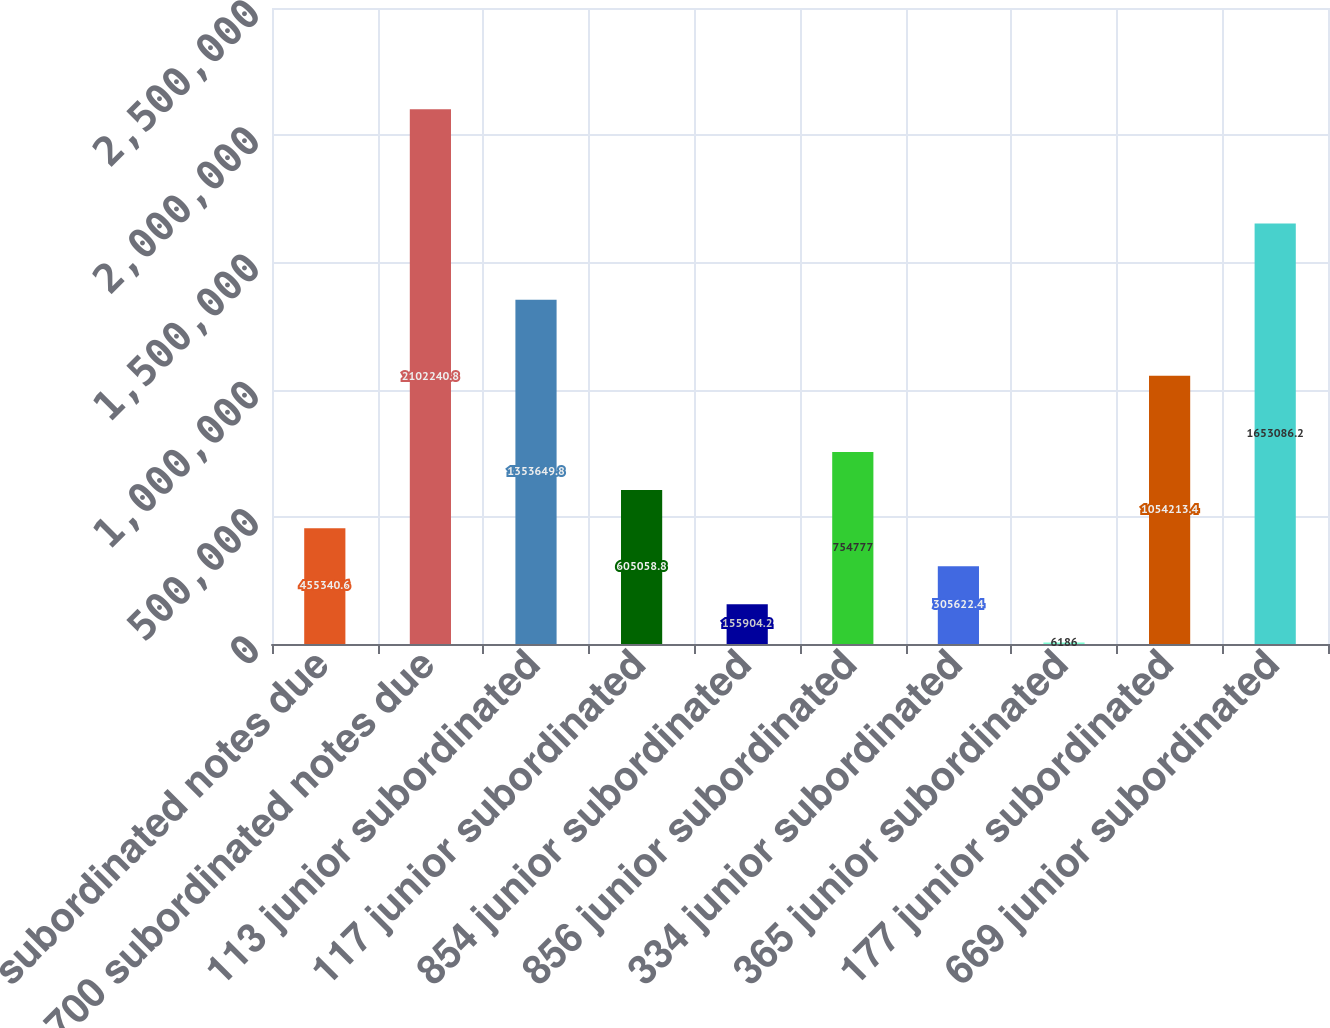Convert chart. <chart><loc_0><loc_0><loc_500><loc_500><bar_chart><fcel>621 subordinated notes due<fcel>700 subordinated notes due<fcel>113 junior subordinated<fcel>117 junior subordinated<fcel>854 junior subordinated<fcel>856 junior subordinated<fcel>334 junior subordinated<fcel>365 junior subordinated<fcel>177 junior subordinated<fcel>669 junior subordinated<nl><fcel>455341<fcel>2.10224e+06<fcel>1.35365e+06<fcel>605059<fcel>155904<fcel>754777<fcel>305622<fcel>6186<fcel>1.05421e+06<fcel>1.65309e+06<nl></chart> 